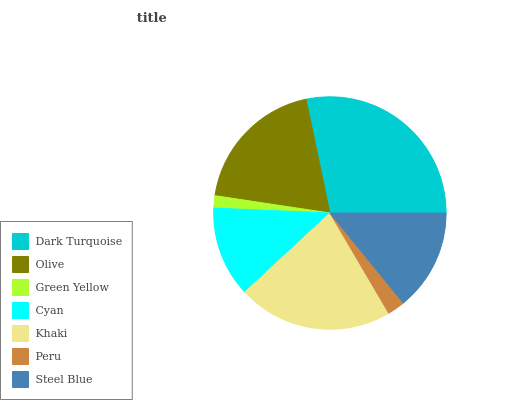Is Green Yellow the minimum?
Answer yes or no. Yes. Is Dark Turquoise the maximum?
Answer yes or no. Yes. Is Olive the minimum?
Answer yes or no. No. Is Olive the maximum?
Answer yes or no. No. Is Dark Turquoise greater than Olive?
Answer yes or no. Yes. Is Olive less than Dark Turquoise?
Answer yes or no. Yes. Is Olive greater than Dark Turquoise?
Answer yes or no. No. Is Dark Turquoise less than Olive?
Answer yes or no. No. Is Steel Blue the high median?
Answer yes or no. Yes. Is Steel Blue the low median?
Answer yes or no. Yes. Is Peru the high median?
Answer yes or no. No. Is Peru the low median?
Answer yes or no. No. 